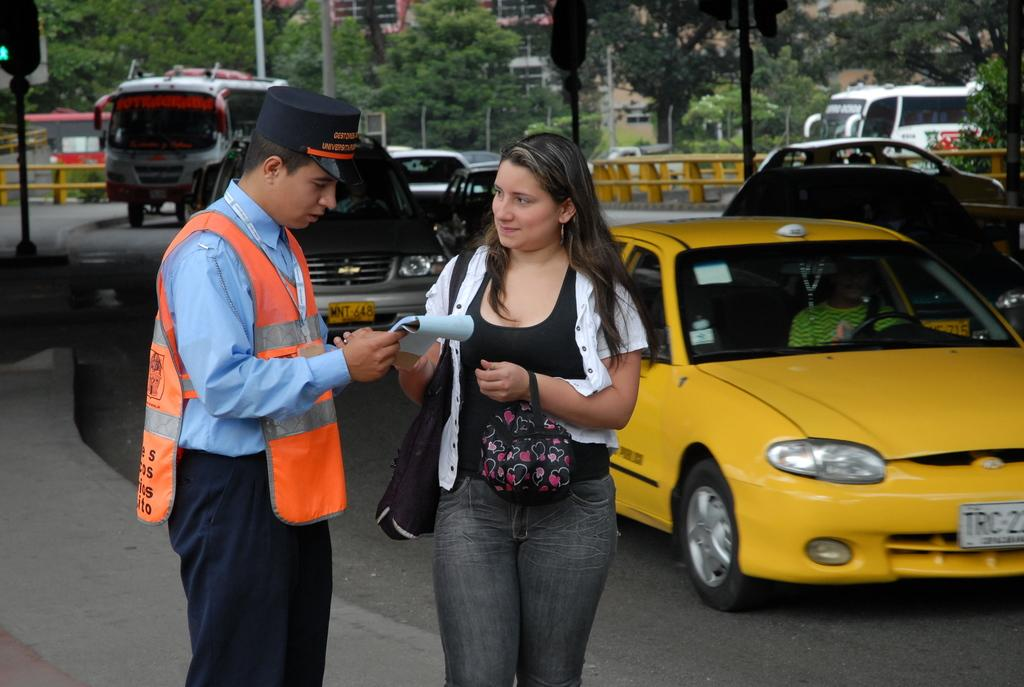<image>
Give a short and clear explanation of the subsequent image. Officer giving a woman a ticket near a car that has a license plate of "MNT-648". 